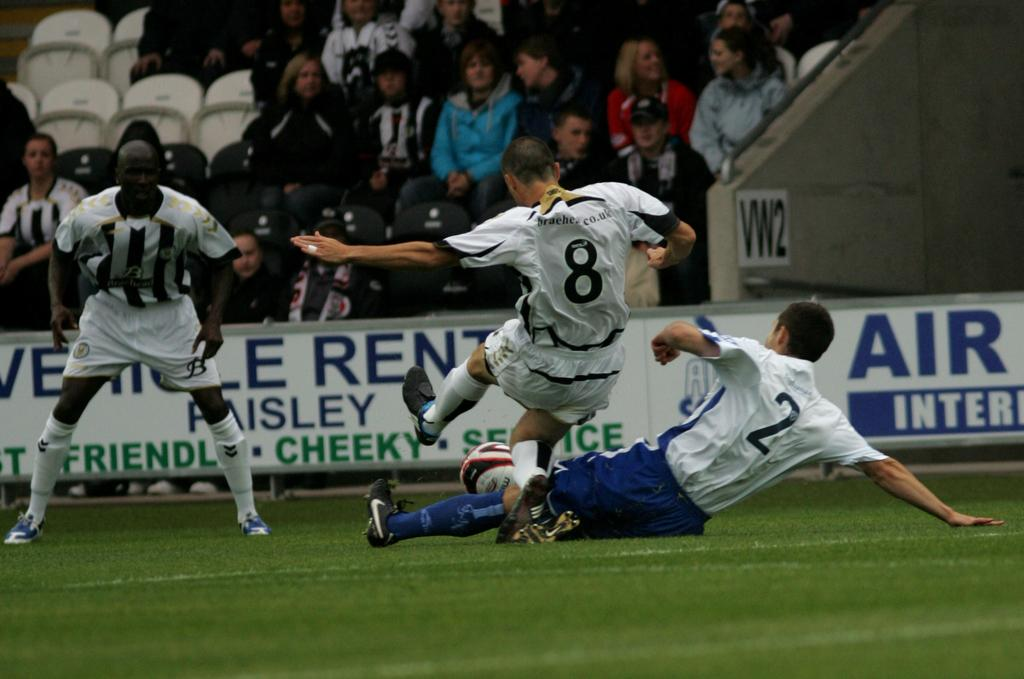How many people are playing football in the image? There are three players in the image. What sport are the players engaged in? The players are playing football. Can you describe the scene beyond the players? There are spectators in the background of the image. What type of voyage is depicted in the image? There is no voyage depicted in the image; it features three players playing football. 